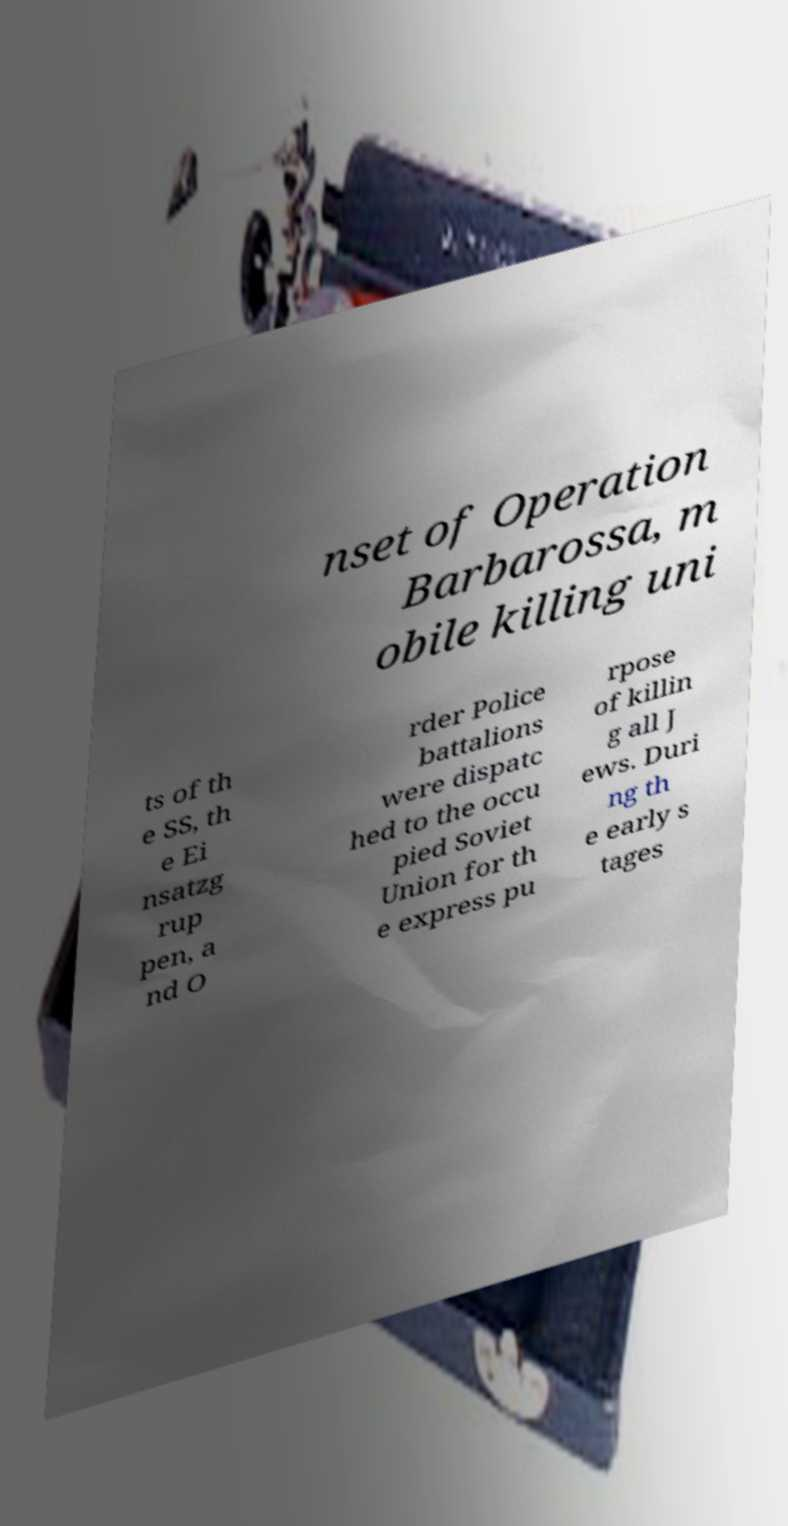Please identify and transcribe the text found in this image. nset of Operation Barbarossa, m obile killing uni ts of th e SS, th e Ei nsatzg rup pen, a nd O rder Police battalions were dispatc hed to the occu pied Soviet Union for th e express pu rpose of killin g all J ews. Duri ng th e early s tages 